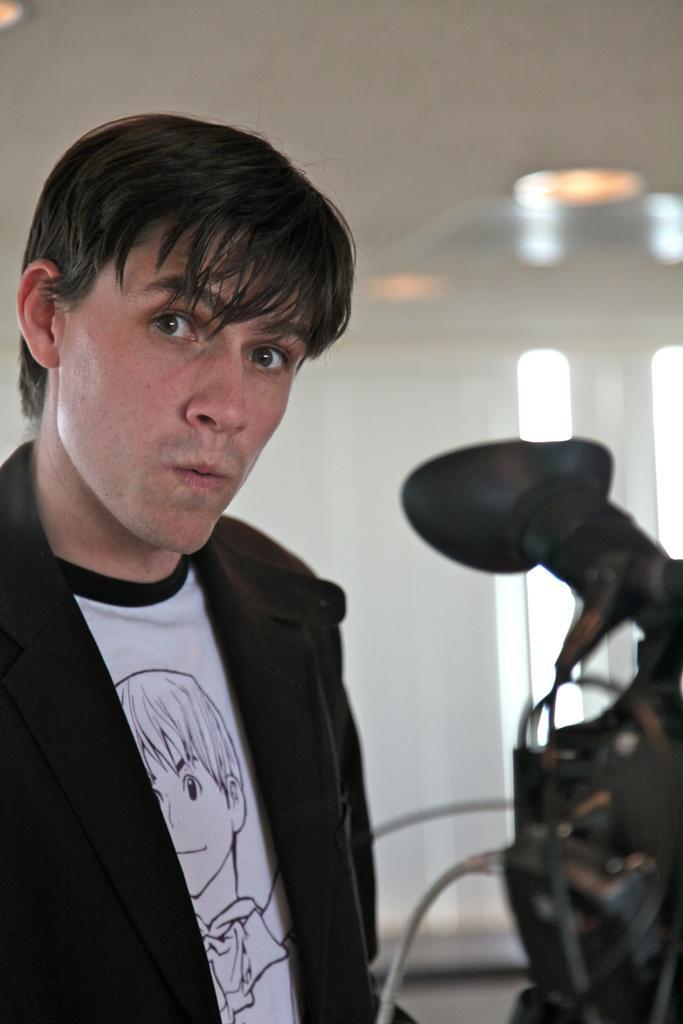Please provide a concise description of this image. In this image on the left side I can see a person. At the top I can see the light. 